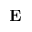Convert formula to latex. <formula><loc_0><loc_0><loc_500><loc_500>E</formula> 